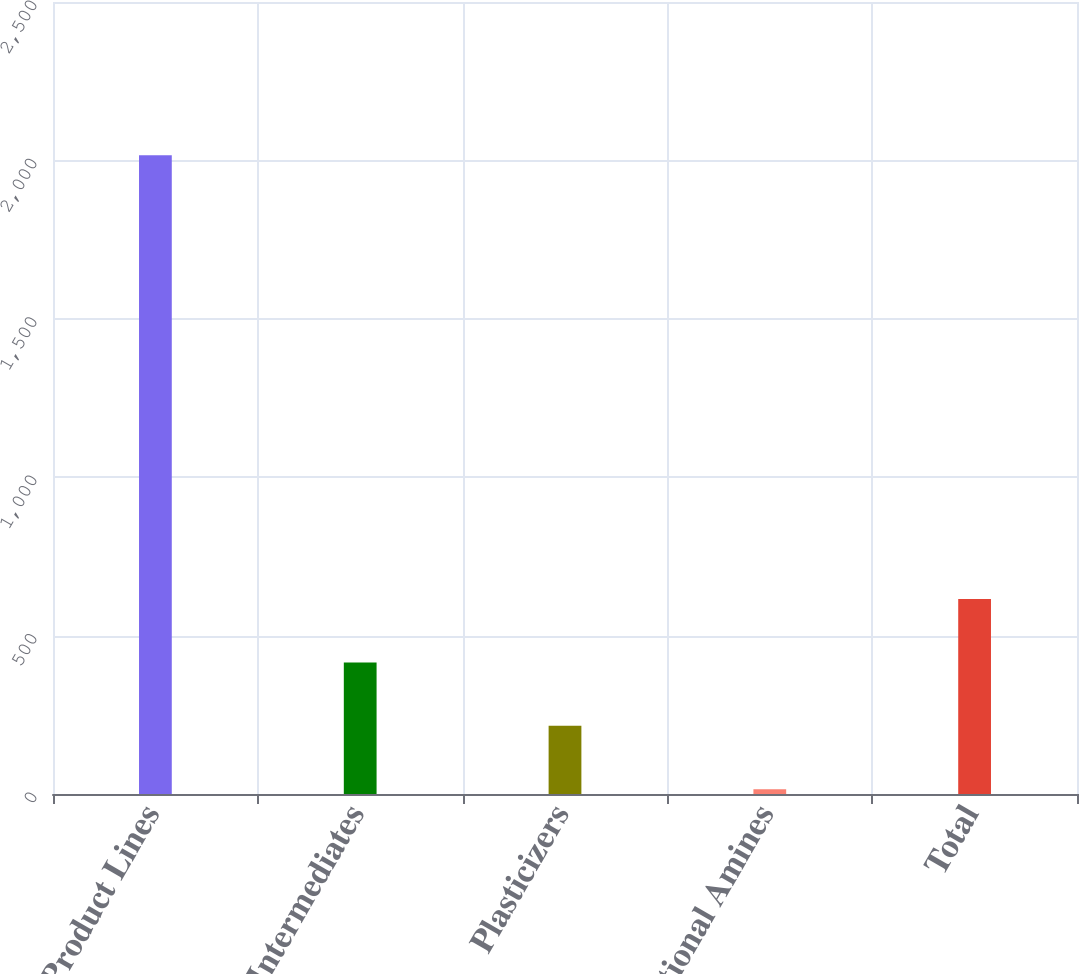<chart> <loc_0><loc_0><loc_500><loc_500><bar_chart><fcel>Product Lines<fcel>Intermediates<fcel>Plasticizers<fcel>Functional Amines<fcel>Total<nl><fcel>2016<fcel>415.2<fcel>215.1<fcel>15<fcel>615.3<nl></chart> 